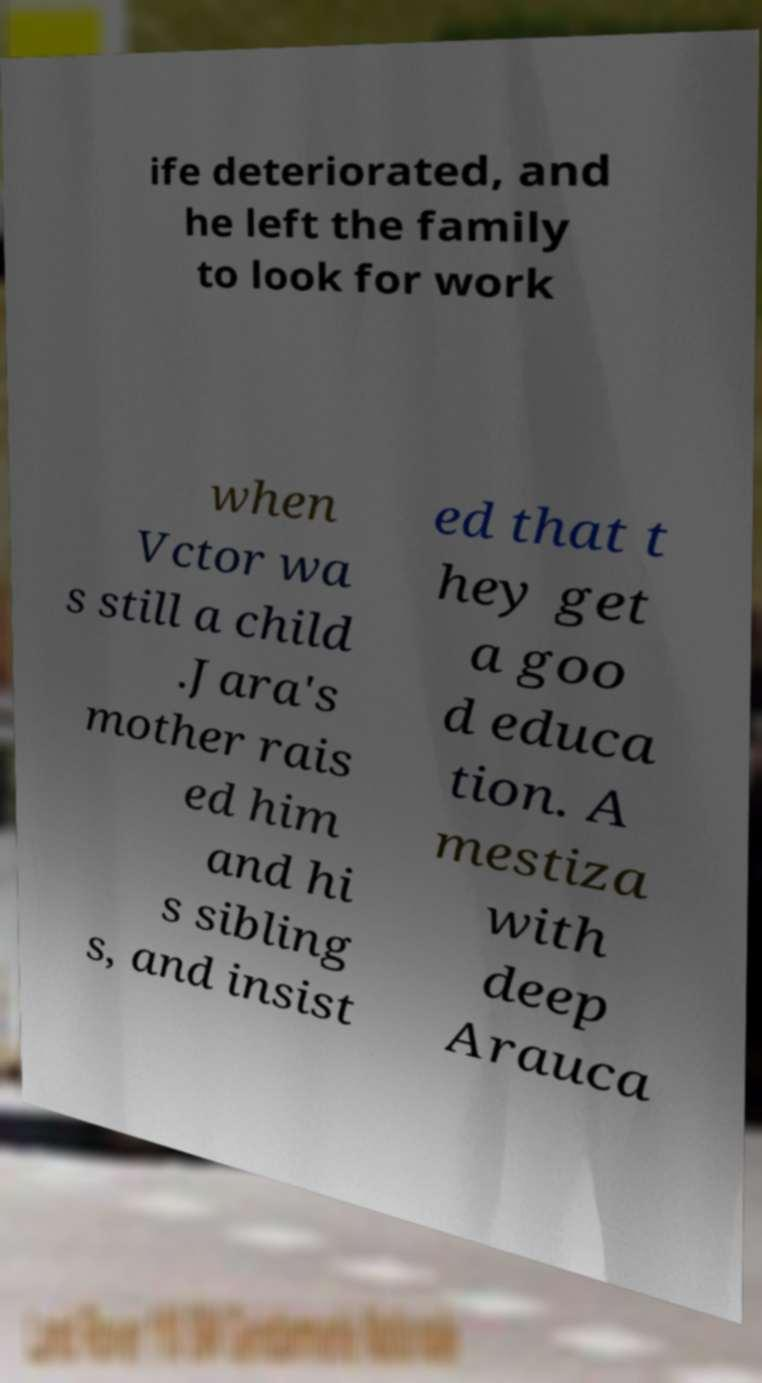I need the written content from this picture converted into text. Can you do that? ife deteriorated, and he left the family to look for work when Vctor wa s still a child .Jara's mother rais ed him and hi s sibling s, and insist ed that t hey get a goo d educa tion. A mestiza with deep Arauca 